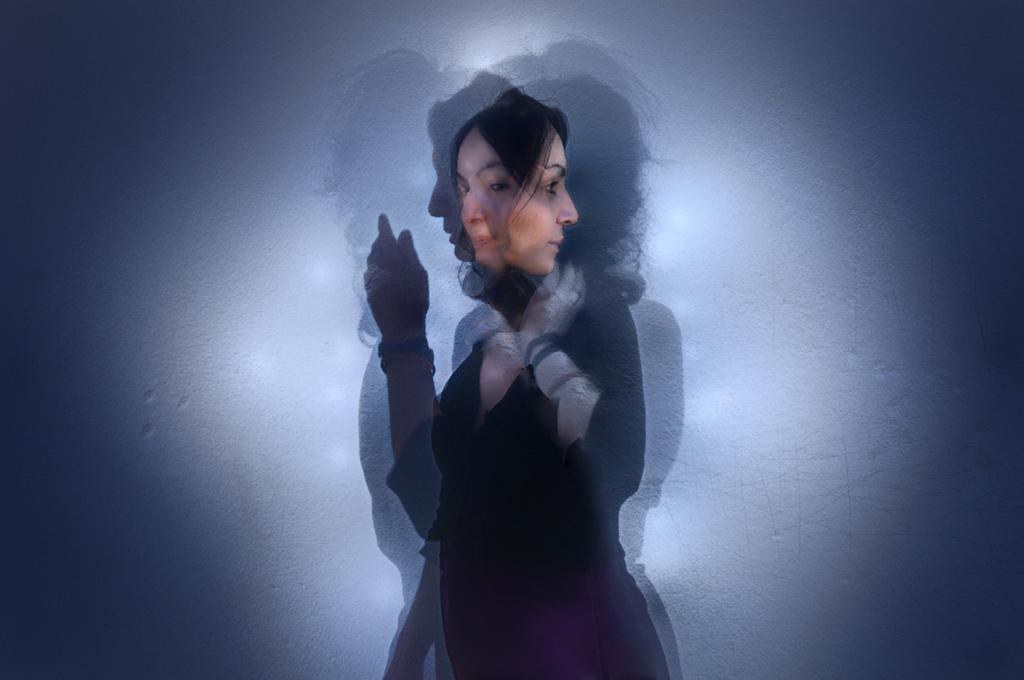What is the main subject of the image? There is a person in the image. What color is the background of the image? The background of the image is blue. What type of yam is being weighed on the scale in the image? There is no scale or yam present in the image; it only features a person with a blue background. 